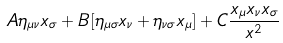Convert formula to latex. <formula><loc_0><loc_0><loc_500><loc_500>A \eta _ { \mu \nu } x _ { \sigma } + B [ \eta _ { \mu \sigma } x _ { \nu } + \eta _ { \nu \sigma } x _ { \mu } ] + C \frac { x _ { \mu } x _ { \nu } x _ { \sigma } } { x ^ { 2 } }</formula> 